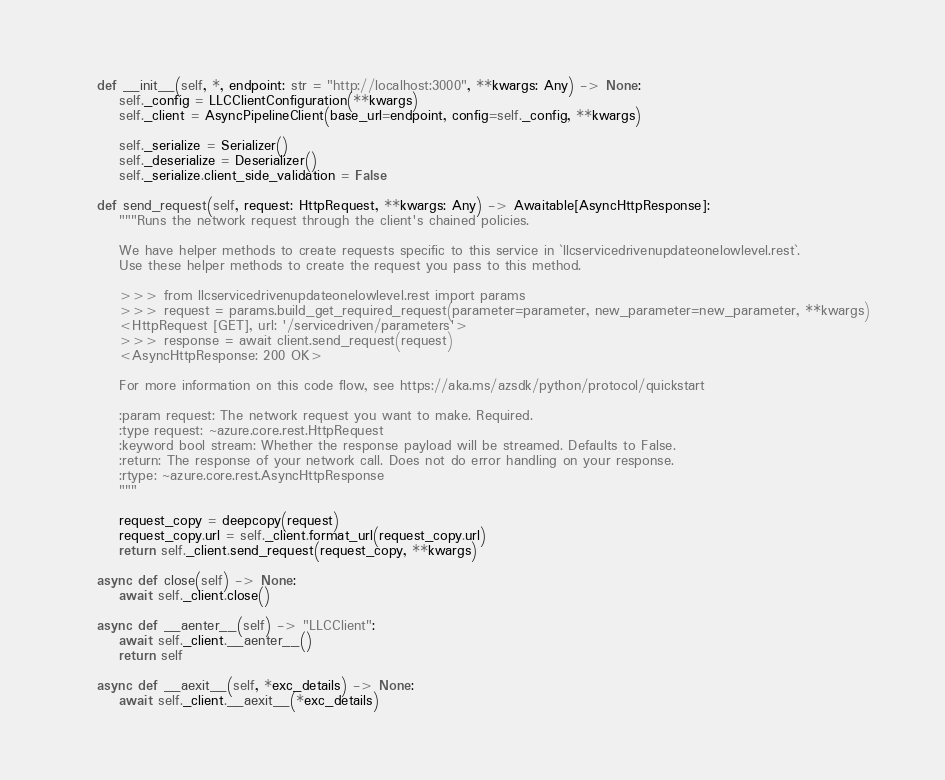<code> <loc_0><loc_0><loc_500><loc_500><_Python_>    def __init__(self, *, endpoint: str = "http://localhost:3000", **kwargs: Any) -> None:
        self._config = LLCClientConfiguration(**kwargs)
        self._client = AsyncPipelineClient(base_url=endpoint, config=self._config, **kwargs)

        self._serialize = Serializer()
        self._deserialize = Deserializer()
        self._serialize.client_side_validation = False

    def send_request(self, request: HttpRequest, **kwargs: Any) -> Awaitable[AsyncHttpResponse]:
        """Runs the network request through the client's chained policies.

        We have helper methods to create requests specific to this service in `llcservicedrivenupdateonelowlevel.rest`.
        Use these helper methods to create the request you pass to this method.

        >>> from llcservicedrivenupdateonelowlevel.rest import params
        >>> request = params.build_get_required_request(parameter=parameter, new_parameter=new_parameter, **kwargs)
        <HttpRequest [GET], url: '/servicedriven/parameters'>
        >>> response = await client.send_request(request)
        <AsyncHttpResponse: 200 OK>

        For more information on this code flow, see https://aka.ms/azsdk/python/protocol/quickstart

        :param request: The network request you want to make. Required.
        :type request: ~azure.core.rest.HttpRequest
        :keyword bool stream: Whether the response payload will be streamed. Defaults to False.
        :return: The response of your network call. Does not do error handling on your response.
        :rtype: ~azure.core.rest.AsyncHttpResponse
        """

        request_copy = deepcopy(request)
        request_copy.url = self._client.format_url(request_copy.url)
        return self._client.send_request(request_copy, **kwargs)

    async def close(self) -> None:
        await self._client.close()

    async def __aenter__(self) -> "LLCClient":
        await self._client.__aenter__()
        return self

    async def __aexit__(self, *exc_details) -> None:
        await self._client.__aexit__(*exc_details)
</code> 